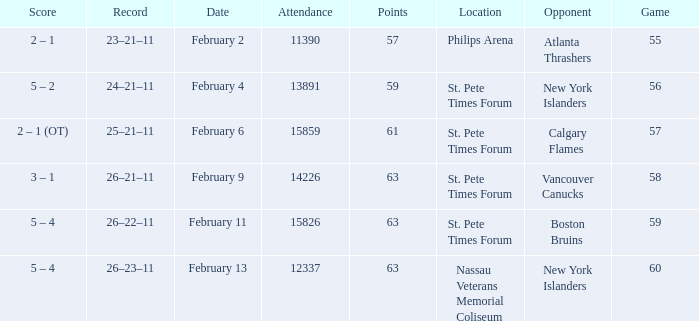What scores happened to be on February 9? 3 – 1. 